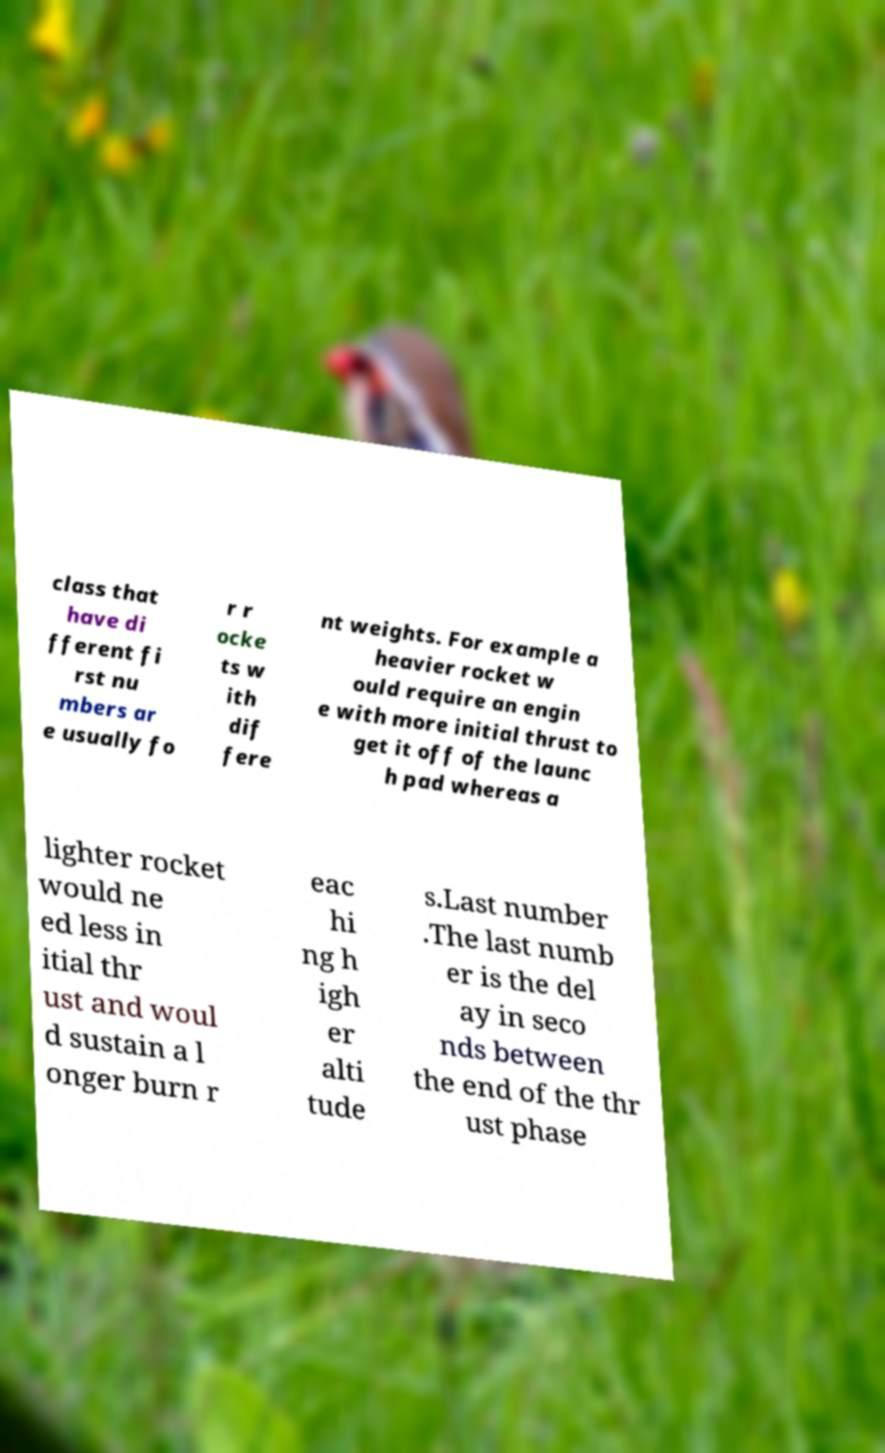Can you read and provide the text displayed in the image?This photo seems to have some interesting text. Can you extract and type it out for me? class that have di fferent fi rst nu mbers ar e usually fo r r ocke ts w ith dif fere nt weights. For example a heavier rocket w ould require an engin e with more initial thrust to get it off of the launc h pad whereas a lighter rocket would ne ed less in itial thr ust and woul d sustain a l onger burn r eac hi ng h igh er alti tude s.Last number .The last numb er is the del ay in seco nds between the end of the thr ust phase 